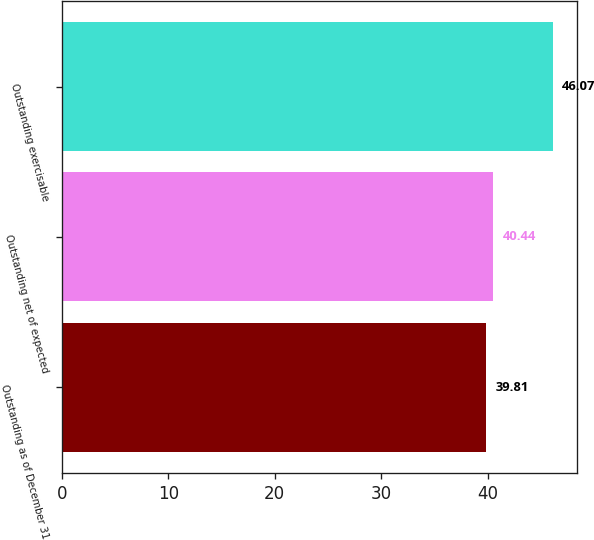Convert chart. <chart><loc_0><loc_0><loc_500><loc_500><bar_chart><fcel>Outstanding as of December 31<fcel>Outstanding net of expected<fcel>Outstanding exercisable<nl><fcel>39.81<fcel>40.44<fcel>46.07<nl></chart> 